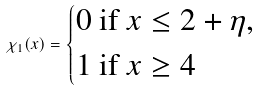Convert formula to latex. <formula><loc_0><loc_0><loc_500><loc_500>\chi _ { 1 } ( x ) = \begin{dcases} 0 \text { if } x \leq 2 + \eta , \\ 1 \text { if } x \geq 4 \end{dcases}</formula> 